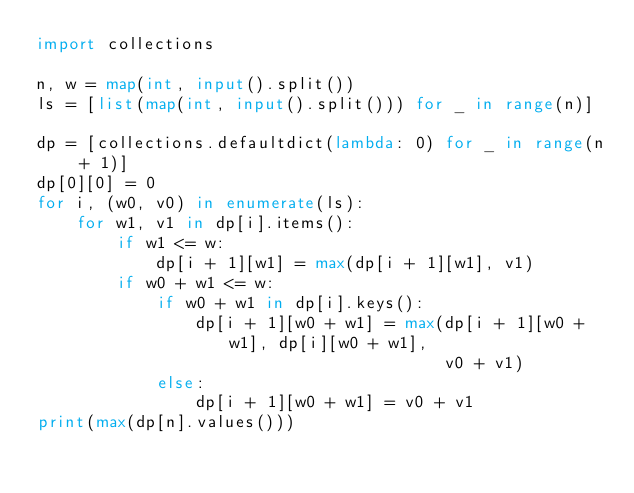<code> <loc_0><loc_0><loc_500><loc_500><_Python_>import collections

n, w = map(int, input().split())
ls = [list(map(int, input().split())) for _ in range(n)]

dp = [collections.defaultdict(lambda: 0) for _ in range(n + 1)]
dp[0][0] = 0
for i, (w0, v0) in enumerate(ls):
    for w1, v1 in dp[i].items():
        if w1 <= w:
            dp[i + 1][w1] = max(dp[i + 1][w1], v1)
        if w0 + w1 <= w:
            if w0 + w1 in dp[i].keys():
                dp[i + 1][w0 + w1] = max(dp[i + 1][w0 + w1], dp[i][w0 + w1],
                                         v0 + v1)
            else:
                dp[i + 1][w0 + w1] = v0 + v1
print(max(dp[n].values()))</code> 